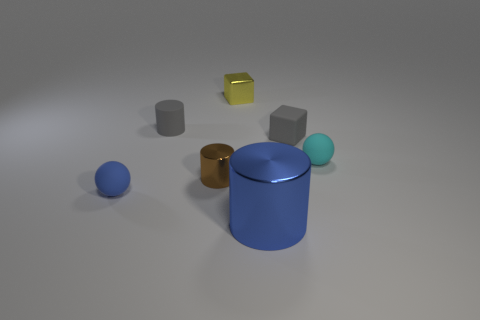How many objects are tiny blue matte cylinders or small spheres that are behind the blue matte sphere?
Provide a short and direct response. 1. There is a cylinder that is behind the ball that is right of the small gray matte thing on the right side of the large blue object; what is it made of?
Your response must be concise. Rubber. What is the size of the brown object that is made of the same material as the tiny yellow thing?
Your answer should be compact. Small. What is the color of the sphere that is left of the blue shiny object in front of the yellow metal block?
Provide a short and direct response. Blue. How many tiny blue balls are the same material as the big blue object?
Provide a succinct answer. 0. What number of shiny things are small brown cylinders or large brown things?
Your response must be concise. 1. There is a gray cube that is the same size as the brown shiny object; what is it made of?
Offer a terse response. Rubber. Are there any blue things that have the same material as the brown cylinder?
Offer a very short reply. Yes. What is the shape of the blue object right of the metallic cylinder that is behind the small rubber sphere that is on the left side of the yellow metallic cube?
Ensure brevity in your answer.  Cylinder. Is the size of the matte block the same as the cylinder that is to the right of the small brown shiny object?
Offer a very short reply. No. 